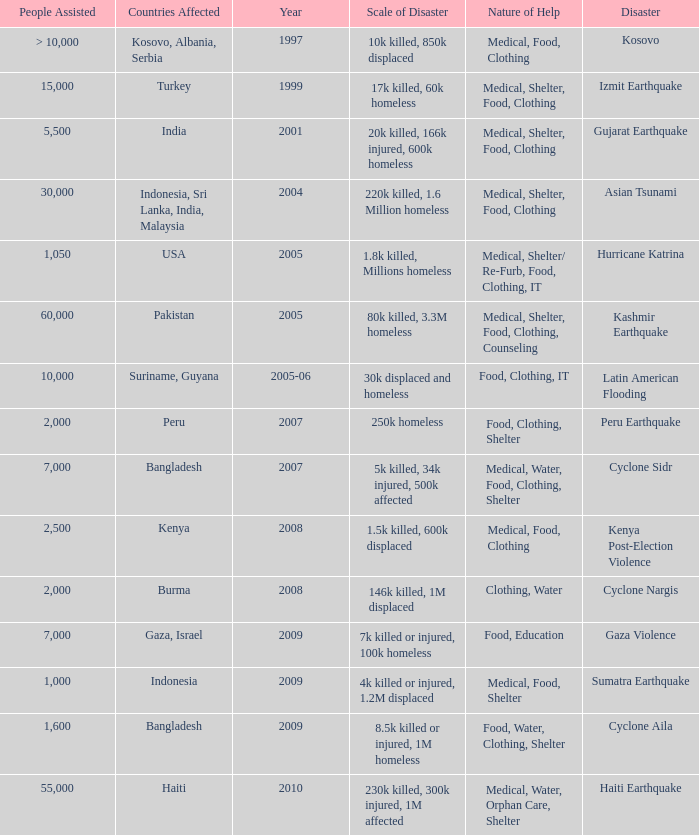In the disaster in which 1,000 people were helped, what was the nature of help? Medical, Food, Shelter. 